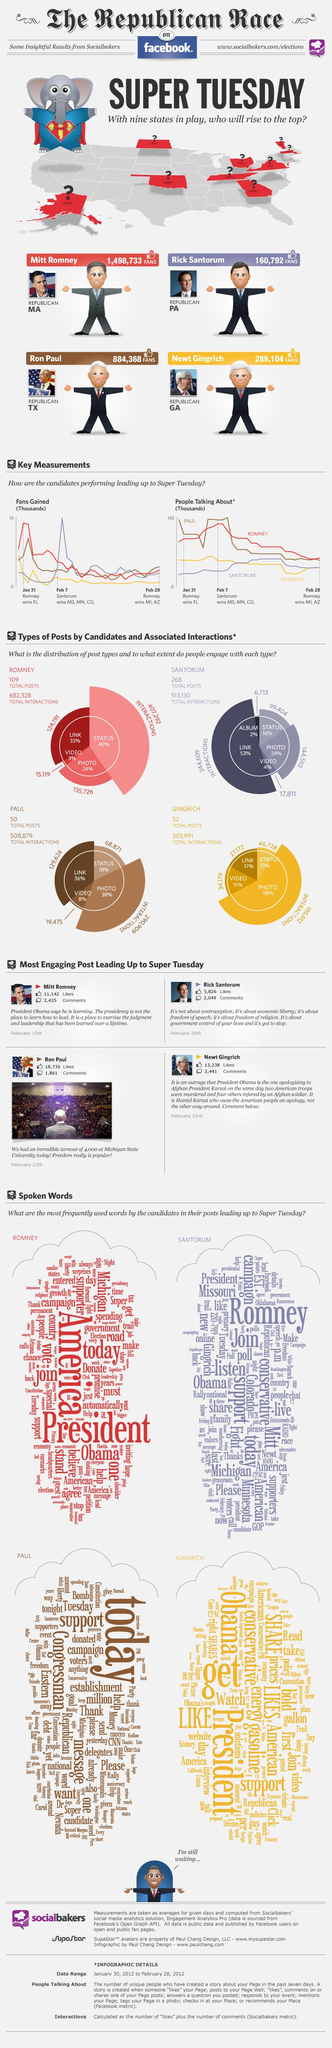Give some essential details in this illustration. Rick Santorum, the Republican representative from Pennsylvania, is known to have the least number of fans among his colleagues. Ron Paul had 129,624 interactions through links. Rick Santorum frequently spoke the word "Romney" more than any other word during his time. In February, Newt Gingrich was the candidate mentioned by people who dropped in. The least percentage of status updates was 10%. 